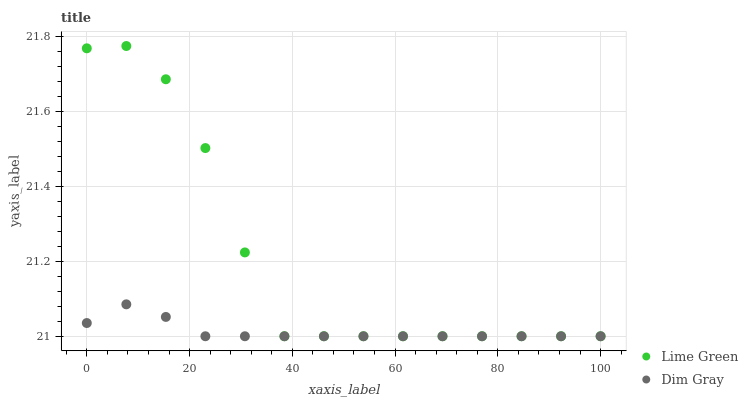Does Dim Gray have the minimum area under the curve?
Answer yes or no. Yes. Does Lime Green have the maximum area under the curve?
Answer yes or no. Yes. Does Lime Green have the minimum area under the curve?
Answer yes or no. No. Is Dim Gray the smoothest?
Answer yes or no. Yes. Is Lime Green the roughest?
Answer yes or no. Yes. Is Lime Green the smoothest?
Answer yes or no. No. Does Dim Gray have the lowest value?
Answer yes or no. Yes. Does Lime Green have the highest value?
Answer yes or no. Yes. Does Lime Green intersect Dim Gray?
Answer yes or no. Yes. Is Lime Green less than Dim Gray?
Answer yes or no. No. Is Lime Green greater than Dim Gray?
Answer yes or no. No. 